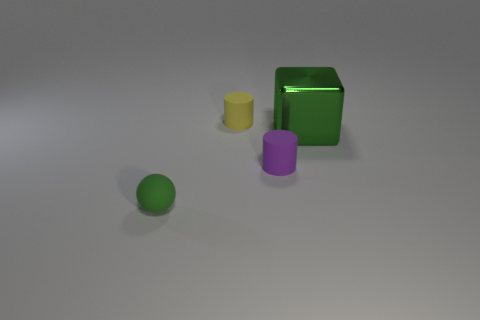The green object that is behind the tiny cylinder in front of the green object that is behind the small green object is made of what material?
Make the answer very short. Metal. Is the shape of the purple thing that is in front of the small yellow matte thing the same as the tiny matte thing behind the big block?
Your answer should be compact. Yes. Are there any metal things that have the same size as the green ball?
Your answer should be compact. No. What number of gray things are either large cylinders or large things?
Make the answer very short. 0. What number of big shiny things are the same color as the tiny rubber ball?
Offer a very short reply. 1. Is there any other thing that has the same shape as the tiny green matte thing?
Offer a very short reply. No. What number of cylinders are either small purple matte objects or large objects?
Give a very brief answer. 1. There is a cylinder in front of the yellow cylinder; what is its color?
Offer a terse response. Purple. What shape is the green rubber thing that is the same size as the yellow object?
Offer a very short reply. Sphere. How many big green cubes are behind the big green block?
Make the answer very short. 0. 